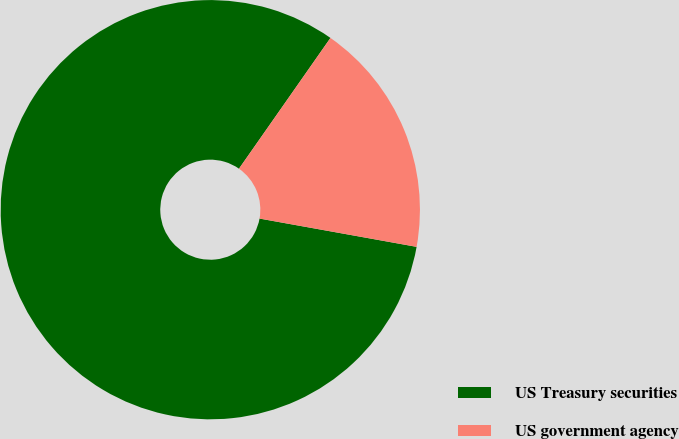Convert chart to OTSL. <chart><loc_0><loc_0><loc_500><loc_500><pie_chart><fcel>US Treasury securities<fcel>US government agency<nl><fcel>81.88%<fcel>18.12%<nl></chart> 